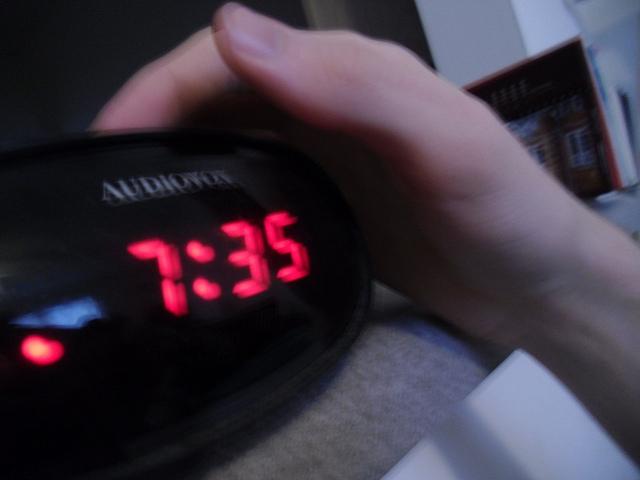Is the clock digital?
Keep it brief. Yes. What time does the clock read?
Short answer required. 7:35. What brand is the clock?
Keep it brief. Audiovox. What time is it?
Short answer required. 7:35. What color is the display on the clock?
Write a very short answer. Red. 